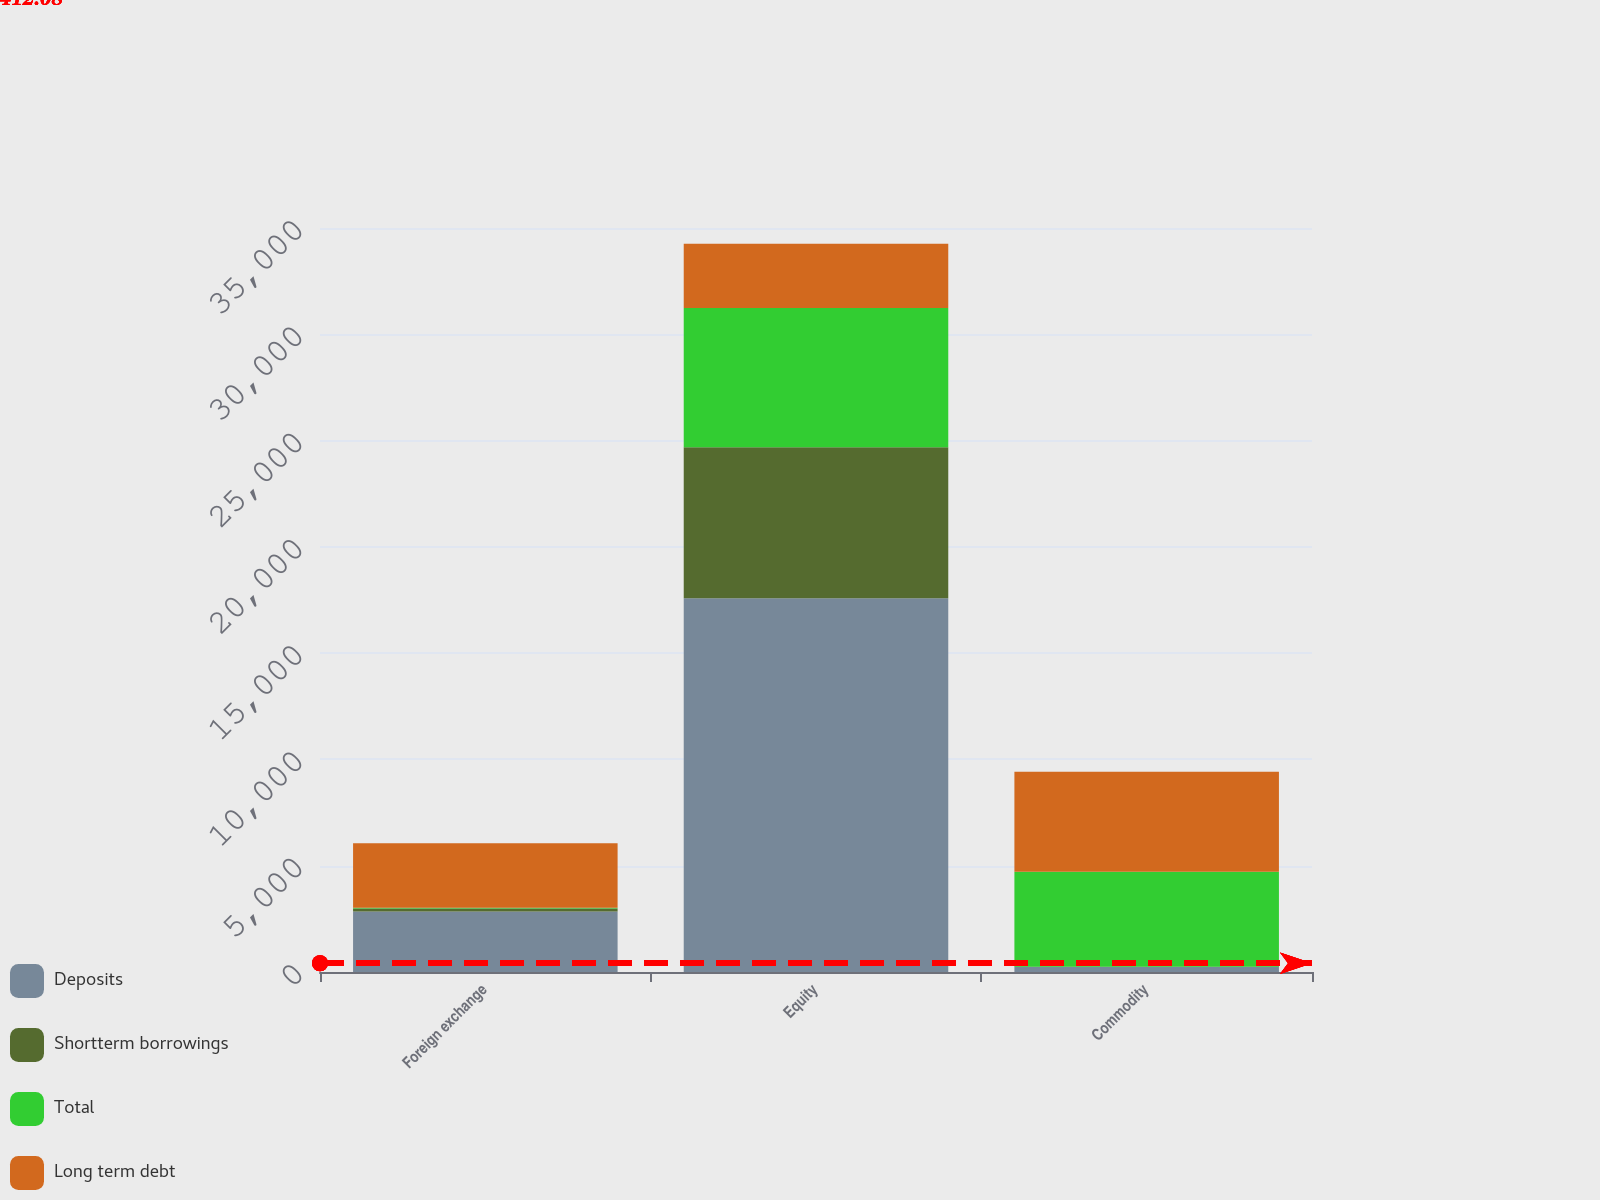<chart> <loc_0><loc_0><loc_500><loc_500><stacked_bar_chart><ecel><fcel>Foreign exchange<fcel>Equity<fcel>Commodity<nl><fcel>Deposits<fcel>2841<fcel>17581<fcel>230<nl><fcel>Shortterm borrowings<fcel>147<fcel>7106<fcel>15<nl><fcel>Total<fcel>38<fcel>6548<fcel>4468<nl><fcel>Long term debt<fcel>3026<fcel>3026<fcel>4713<nl></chart> 